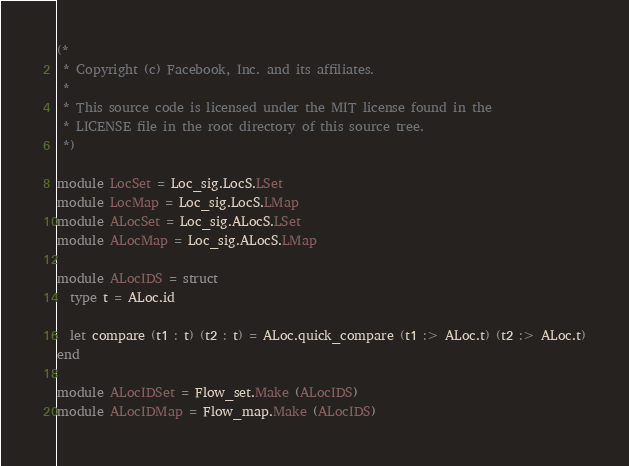Convert code to text. <code><loc_0><loc_0><loc_500><loc_500><_OCaml_>(*
 * Copyright (c) Facebook, Inc. and its affiliates.
 *
 * This source code is licensed under the MIT license found in the
 * LICENSE file in the root directory of this source tree.
 *)

module LocSet = Loc_sig.LocS.LSet
module LocMap = Loc_sig.LocS.LMap
module ALocSet = Loc_sig.ALocS.LSet
module ALocMap = Loc_sig.ALocS.LMap

module ALocIDS = struct
  type t = ALoc.id

  let compare (t1 : t) (t2 : t) = ALoc.quick_compare (t1 :> ALoc.t) (t2 :> ALoc.t)
end

module ALocIDSet = Flow_set.Make (ALocIDS)
module ALocIDMap = Flow_map.Make (ALocIDS)
</code> 